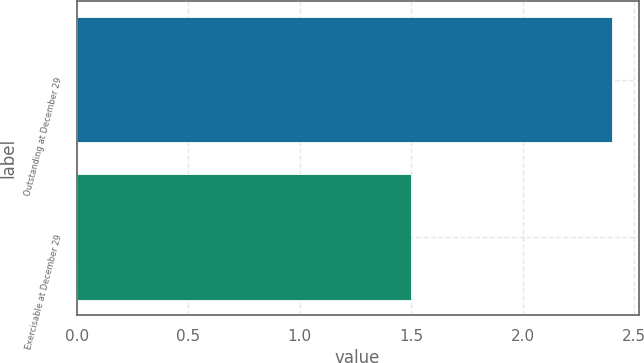<chart> <loc_0><loc_0><loc_500><loc_500><bar_chart><fcel>Outstanding at December 29<fcel>Exercisable at December 29<nl><fcel>2.4<fcel>1.5<nl></chart> 